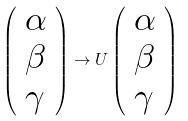Convert formula to latex. <formula><loc_0><loc_0><loc_500><loc_500>\left ( \begin{array} { l } \alpha \\ \beta \\ \gamma \end{array} \right ) \to { U } \left ( \begin{array} { l } \alpha \\ \beta \\ \gamma \end{array} \right )</formula> 